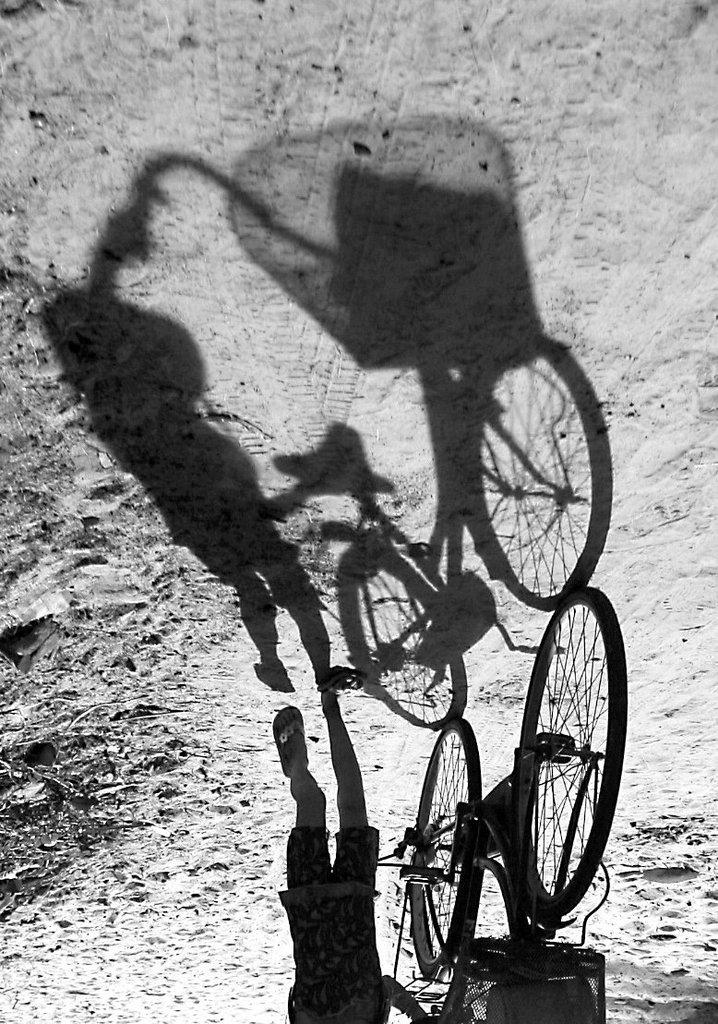What can be seen on the right side of the image? There is a child on the right side of the image. What is the child holding in the image? The child is holding a bicycle. What is the child doing in the image? The child is walking on the road. What can be observed on the road in the image? There is a shadow of the bicycle and the child on the road. What type of lunch is the child eating in the image? There is no indication in the image that the child is eating lunch, so it cannot be determined from the picture. 